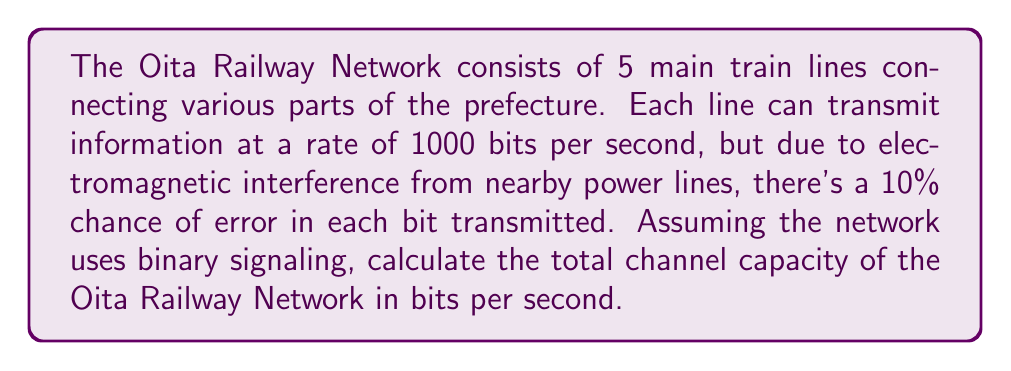Could you help me with this problem? To solve this problem, we'll use the Shannon-Hartley theorem for channel capacity. Let's break it down step-by-step:

1) First, we need to calculate the capacity of a single line. The formula for channel capacity is:

   $$C = B \log_2(1 + SNR)$$

   Where:
   $C$ is the channel capacity in bits per second
   $B$ is the bandwidth in Hz
   $SNR$ is the signal-to-noise ratio

2) In this case, we don't have the SNR directly, but we can calculate it from the error probability. For a binary symmetric channel with error probability $p$, the capacity is:

   $$C = 1 - H(p)$$

   Where $H(p)$ is the binary entropy function:

   $$H(p) = -p \log_2(p) - (1-p) \log_2(1-p)$$

3) Given error probability $p = 0.1$:

   $$H(0.1) = -0.1 \log_2(0.1) - 0.9 \log_2(0.9) \approx 0.469$$

4) Therefore, the capacity of a single line is:

   $$C = 1000 * (1 - 0.469) = 531 \text{ bits/second}$$

5) Since there are 5 independent lines, we multiply this by 5:

   $$C_{total} = 5 * 531 = 2655 \text{ bits/second}$$
Answer: The total channel capacity of the Oita Railway Network is approximately 2655 bits per second. 